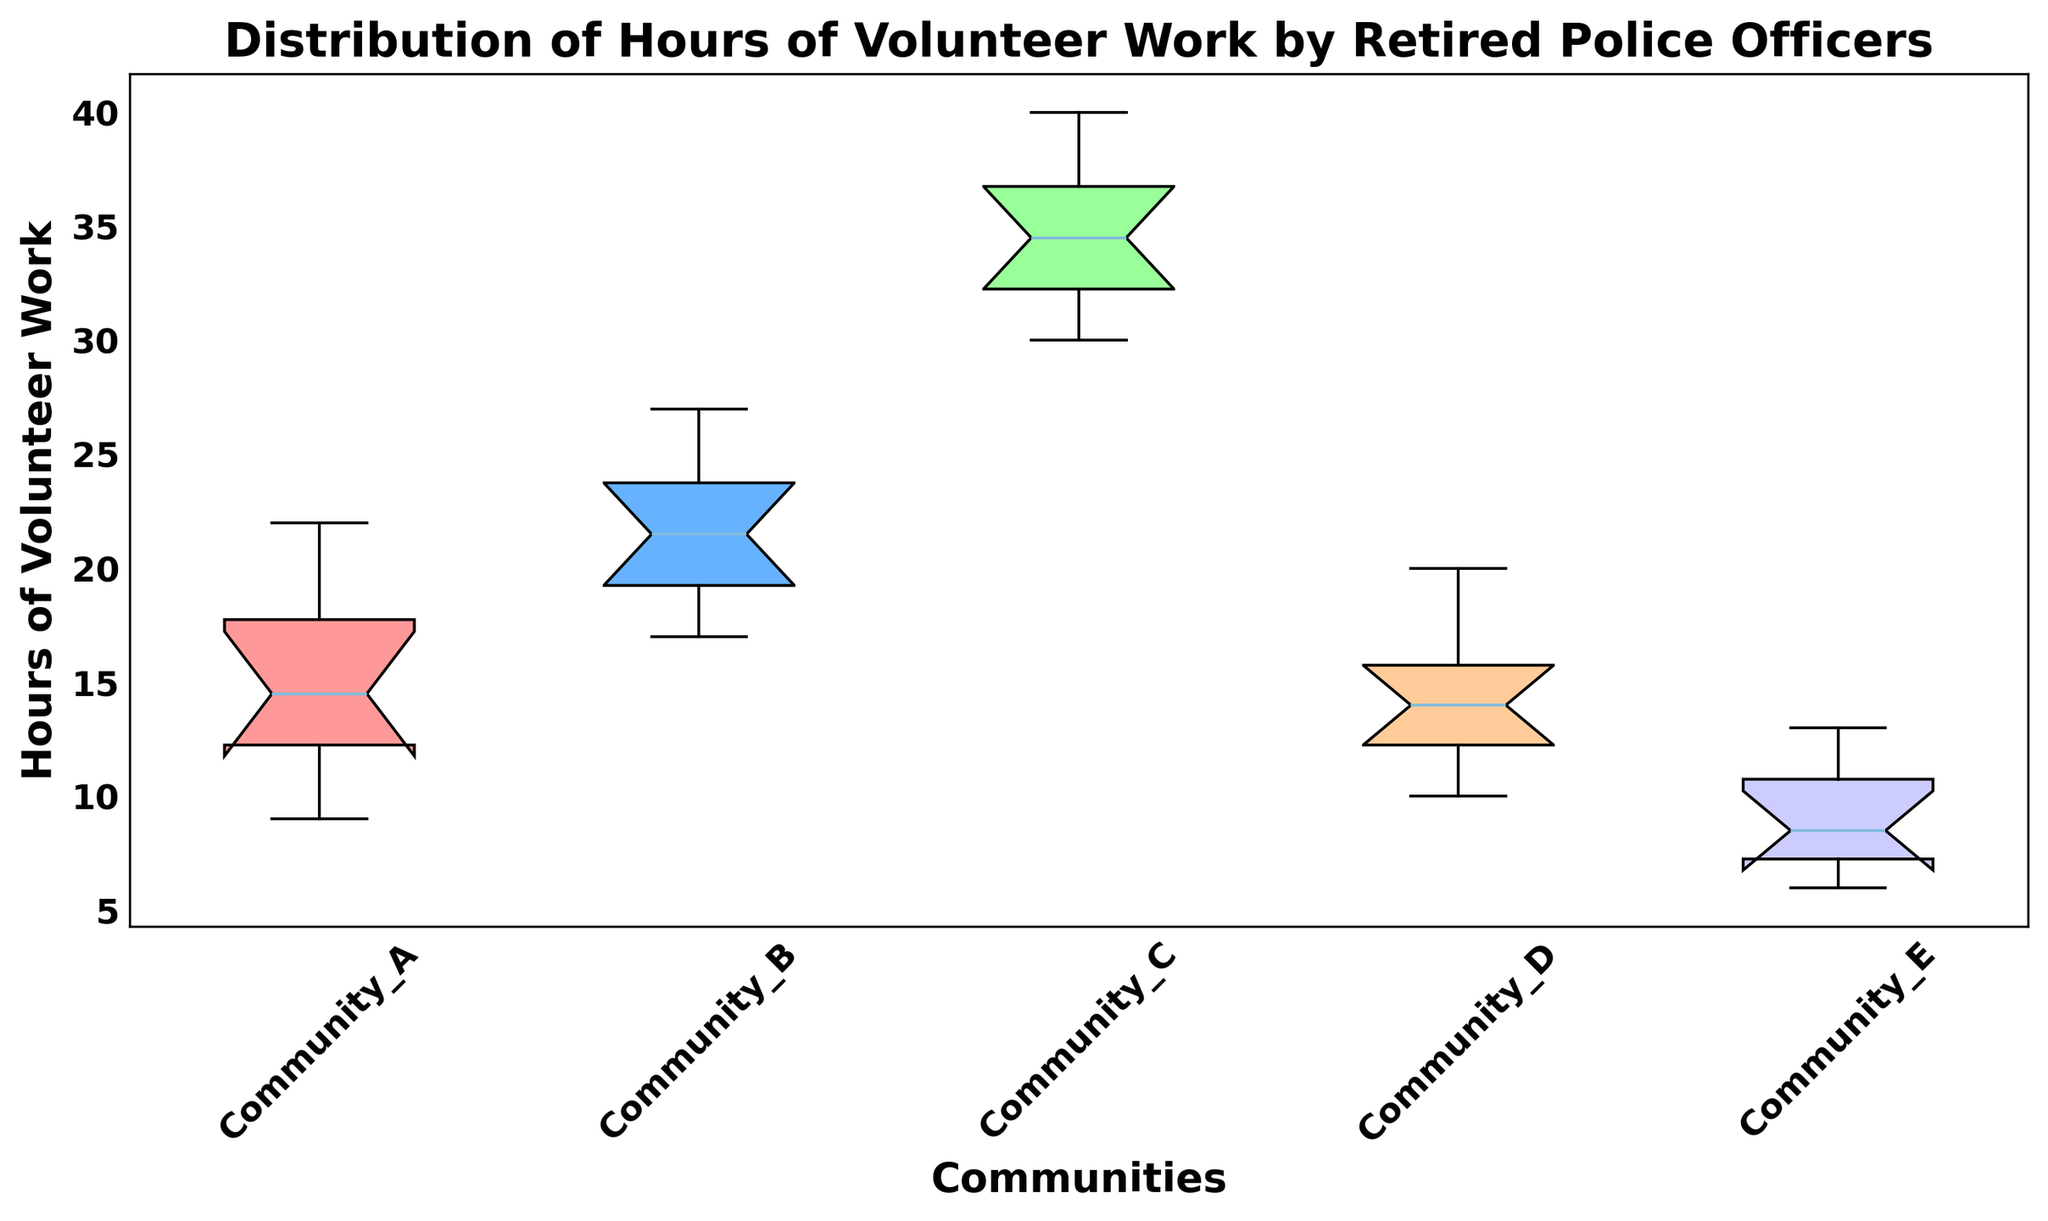What is the range of hours of volunteer work for Community A? To find the range, identify the minimum and maximum values in Community A from the box plot. The range is the difference between these two values.
Answer: 13 Which community has the highest median hours of volunteer work? Look at the central line in each box on the plot, which represents the median. Identify which community's box has the highest median line.
Answer: Community C How do the interquartile ranges (IQR) of Community B and Community E compare? The IQR is the length of the box, which represents the range from the first quartile (Q1) to the third quartile (Q3). Visually compare the lengths of the boxes for Community B and Community E.
Answer: Community B's IQR is larger than Community E's IQR What is the median number of hours of volunteer work for Community D? Identify the central line within the box plot for Community D, which represents the median.
Answer: 14 Which communities have outliers and where are they located? Outliers are represented by points outside the whiskers of the box plots. Identify the communities with such points and their positions.
Answer: None Compare the upper quartile values for Community A and Community D. Which is higher? The upper quartile (Q3) is the top of the box in each box plot. Compare the heights of the tops of the boxes for Community A and Community D visually.
Answer: Community A What does the width of a box in a box plot represent, and which community has the widest box? The width of a box in a box plot typically does not have any significance; it's the height that matters as it represents the IQR. Focus on identifying the largest spread (height) instead.
Answer: Community B Among the communities, which one has the most consistent number of volunteer hours (i.e., the smallest IQR)? The community with the smallest IQR will have the shortest box. Visually inspect the box plots and find the community with the shortest box.
Answer: Community E Is the median volunteer work hours of Community C greater than the third quartile of Community D? Identify and compare the median line of Community C and the top of the box (third quartile) of Community D.
Answer: Yes Which community has the lowest minimum value for volunteer hours? The minimum value is marked by the bottom whisker in each box plot. Identify the community with the lowest bottom whisker.
Answer: Community E 